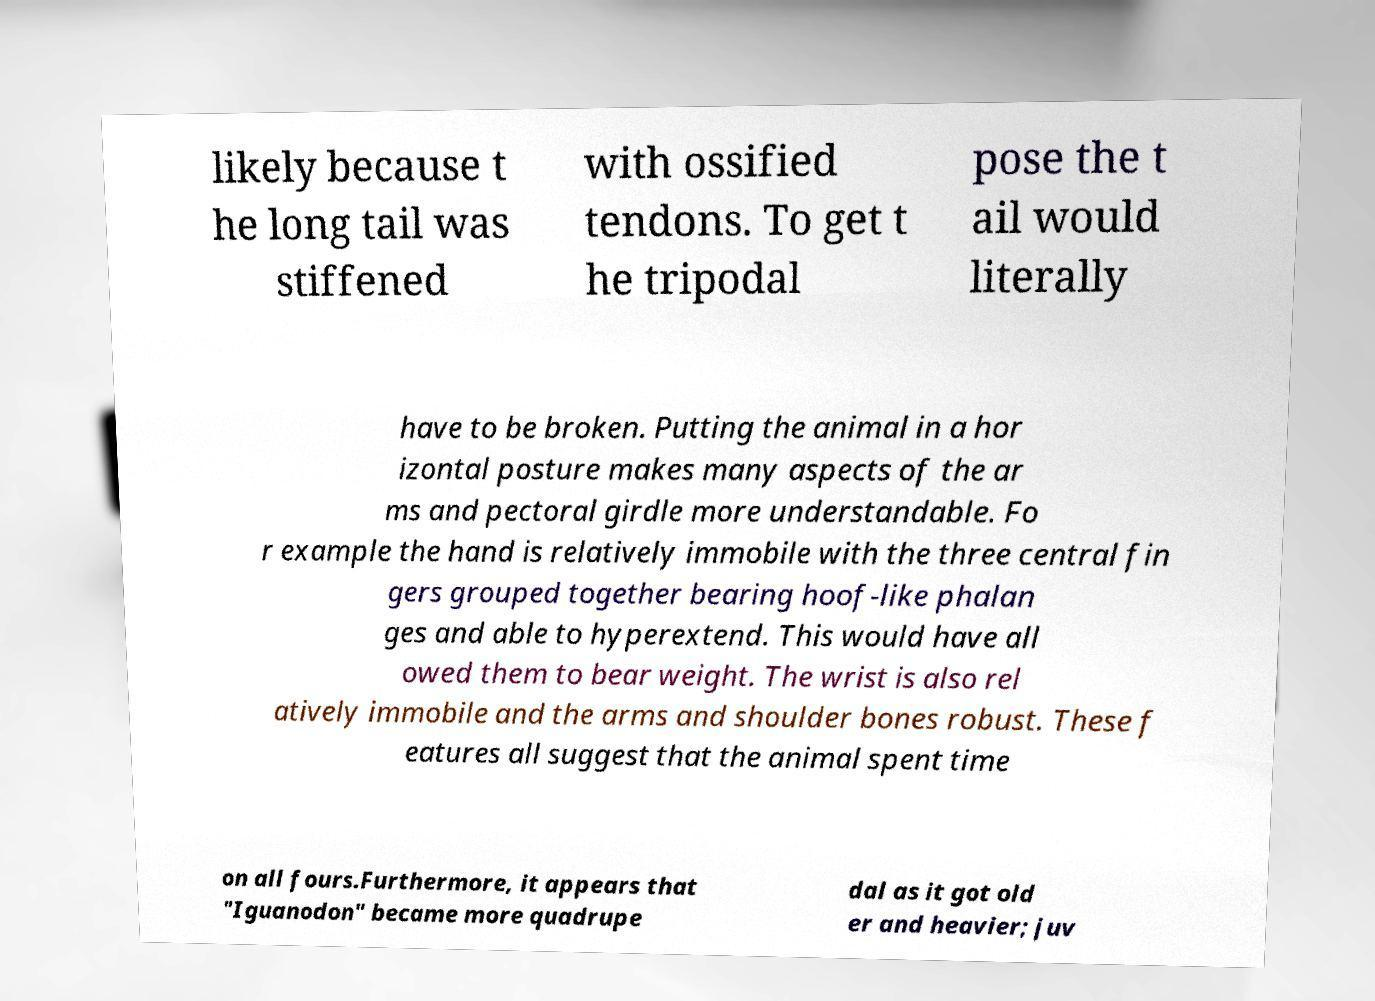Could you extract and type out the text from this image? likely because t he long tail was stiffened with ossified tendons. To get t he tripodal pose the t ail would literally have to be broken. Putting the animal in a hor izontal posture makes many aspects of the ar ms and pectoral girdle more understandable. Fo r example the hand is relatively immobile with the three central fin gers grouped together bearing hoof-like phalan ges and able to hyperextend. This would have all owed them to bear weight. The wrist is also rel atively immobile and the arms and shoulder bones robust. These f eatures all suggest that the animal spent time on all fours.Furthermore, it appears that "Iguanodon" became more quadrupe dal as it got old er and heavier; juv 